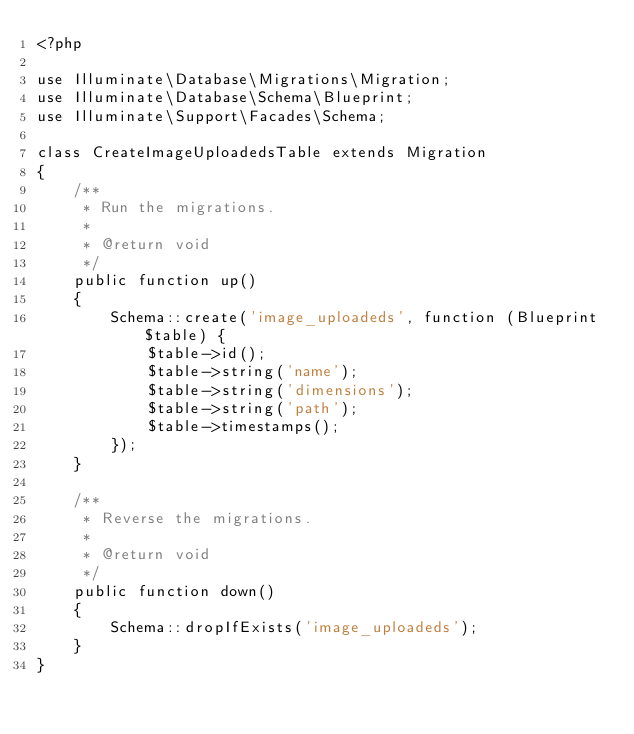<code> <loc_0><loc_0><loc_500><loc_500><_PHP_><?php

use Illuminate\Database\Migrations\Migration;
use Illuminate\Database\Schema\Blueprint;
use Illuminate\Support\Facades\Schema;

class CreateImageUploadedsTable extends Migration
{
    /**
     * Run the migrations.
     *
     * @return void
     */
    public function up()
    {
        Schema::create('image_uploadeds', function (Blueprint $table) {
            $table->id();
            $table->string('name');
            $table->string('dimensions');
            $table->string('path');
            $table->timestamps();
        });
    }

    /**
     * Reverse the migrations.
     *
     * @return void
     */
    public function down()
    {
        Schema::dropIfExists('image_uploadeds');
    }
}
</code> 